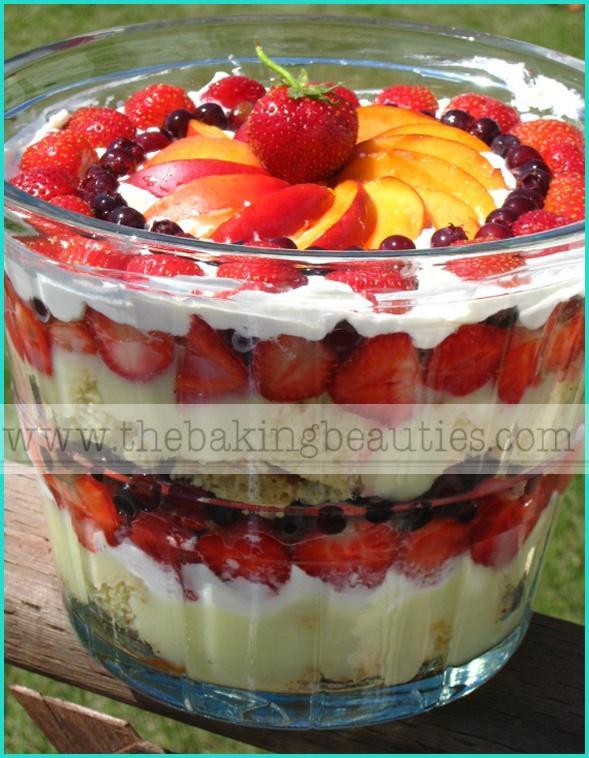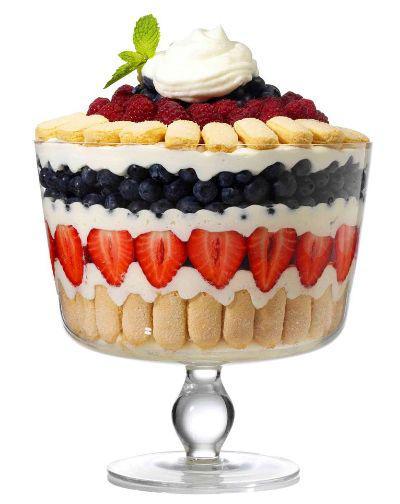The first image is the image on the left, the second image is the image on the right. Given the left and right images, does the statement "At least one dessert is garnished with leaves." hold true? Answer yes or no. Yes. 